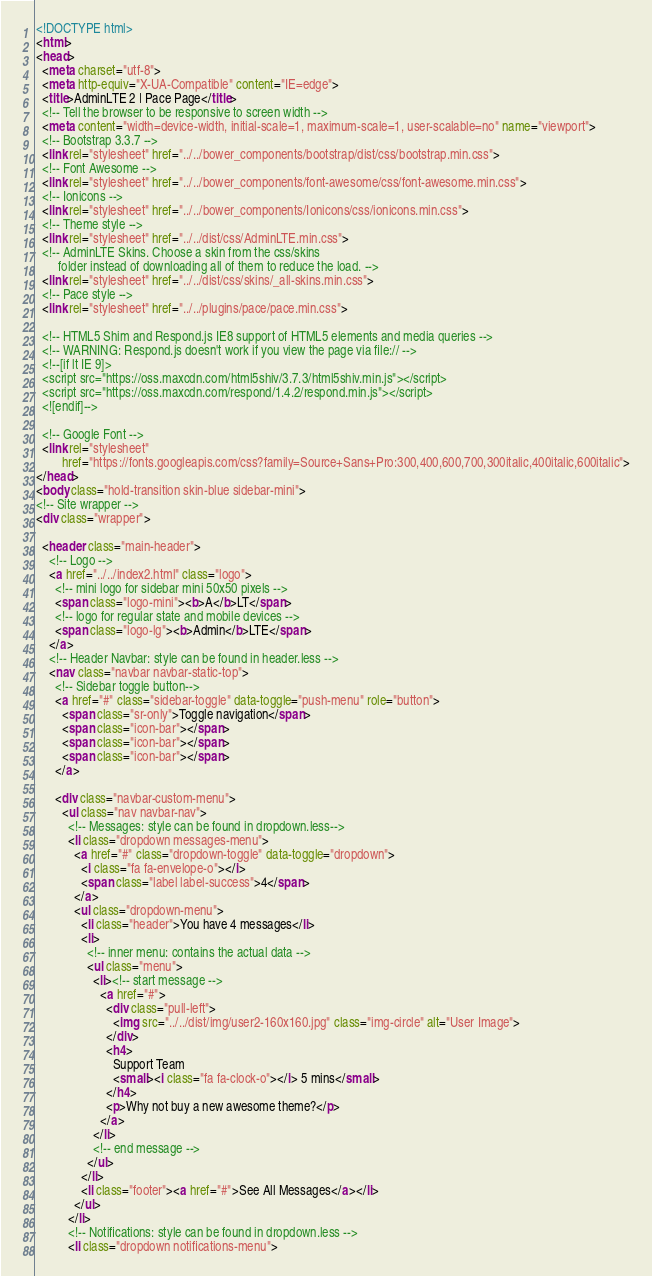Convert code to text. <code><loc_0><loc_0><loc_500><loc_500><_HTML_><!DOCTYPE html>
<html>
<head>
  <meta charset="utf-8">
  <meta http-equiv="X-UA-Compatible" content="IE=edge">
  <title>AdminLTE 2 | Pace Page</title>
  <!-- Tell the browser to be responsive to screen width -->
  <meta content="width=device-width, initial-scale=1, maximum-scale=1, user-scalable=no" name="viewport">
  <!-- Bootstrap 3.3.7 -->
  <link rel="stylesheet" href="../../bower_components/bootstrap/dist/css/bootstrap.min.css">
  <!-- Font Awesome -->
  <link rel="stylesheet" href="../../bower_components/font-awesome/css/font-awesome.min.css">
  <!-- Ionicons -->
  <link rel="stylesheet" href="../../bower_components/Ionicons/css/ionicons.min.css">
  <!-- Theme style -->
  <link rel="stylesheet" href="../../dist/css/AdminLTE.min.css">
  <!-- AdminLTE Skins. Choose a skin from the css/skins
       folder instead of downloading all of them to reduce the load. -->
  <link rel="stylesheet" href="../../dist/css/skins/_all-skins.min.css">
  <!-- Pace style -->
  <link rel="stylesheet" href="../../plugins/pace/pace.min.css">

  <!-- HTML5 Shim and Respond.js IE8 support of HTML5 elements and media queries -->
  <!-- WARNING: Respond.js doesn't work if you view the page via file:// -->
  <!--[if lt IE 9]>
  <script src="https://oss.maxcdn.com/html5shiv/3.7.3/html5shiv.min.js"></script>
  <script src="https://oss.maxcdn.com/respond/1.4.2/respond.min.js"></script>
  <![endif]-->

  <!-- Google Font -->
  <link rel="stylesheet"
        href="https://fonts.googleapis.com/css?family=Source+Sans+Pro:300,400,600,700,300italic,400italic,600italic">
</head>
<body class="hold-transition skin-blue sidebar-mini">
<!-- Site wrapper -->
<div class="wrapper">

  <header class="main-header">
    <!-- Logo -->
    <a href="../../index2.html" class="logo">
      <!-- mini logo for sidebar mini 50x50 pixels -->
      <span class="logo-mini"><b>A</b>LT</span>
      <!-- logo for regular state and mobile devices -->
      <span class="logo-lg"><b>Admin</b>LTE</span>
    </a>
    <!-- Header Navbar: style can be found in header.less -->
    <nav class="navbar navbar-static-top">
      <!-- Sidebar toggle button-->
      <a href="#" class="sidebar-toggle" data-toggle="push-menu" role="button">
        <span class="sr-only">Toggle navigation</span>
        <span class="icon-bar"></span>
        <span class="icon-bar"></span>
        <span class="icon-bar"></span>
      </a>

      <div class="navbar-custom-menu">
        <ul class="nav navbar-nav">
          <!-- Messages: style can be found in dropdown.less-->
          <li class="dropdown messages-menu">
            <a href="#" class="dropdown-toggle" data-toggle="dropdown">
              <i class="fa fa-envelope-o"></i>
              <span class="label label-success">4</span>
            </a>
            <ul class="dropdown-menu">
              <li class="header">You have 4 messages</li>
              <li>
                <!-- inner menu: contains the actual data -->
                <ul class="menu">
                  <li><!-- start message -->
                    <a href="#">
                      <div class="pull-left">
                        <img src="../../dist/img/user2-160x160.jpg" class="img-circle" alt="User Image">
                      </div>
                      <h4>
                        Support Team
                        <small><i class="fa fa-clock-o"></i> 5 mins</small>
                      </h4>
                      <p>Why not buy a new awesome theme?</p>
                    </a>
                  </li>
                  <!-- end message -->
                </ul>
              </li>
              <li class="footer"><a href="#">See All Messages</a></li>
            </ul>
          </li>
          <!-- Notifications: style can be found in dropdown.less -->
          <li class="dropdown notifications-menu"></code> 